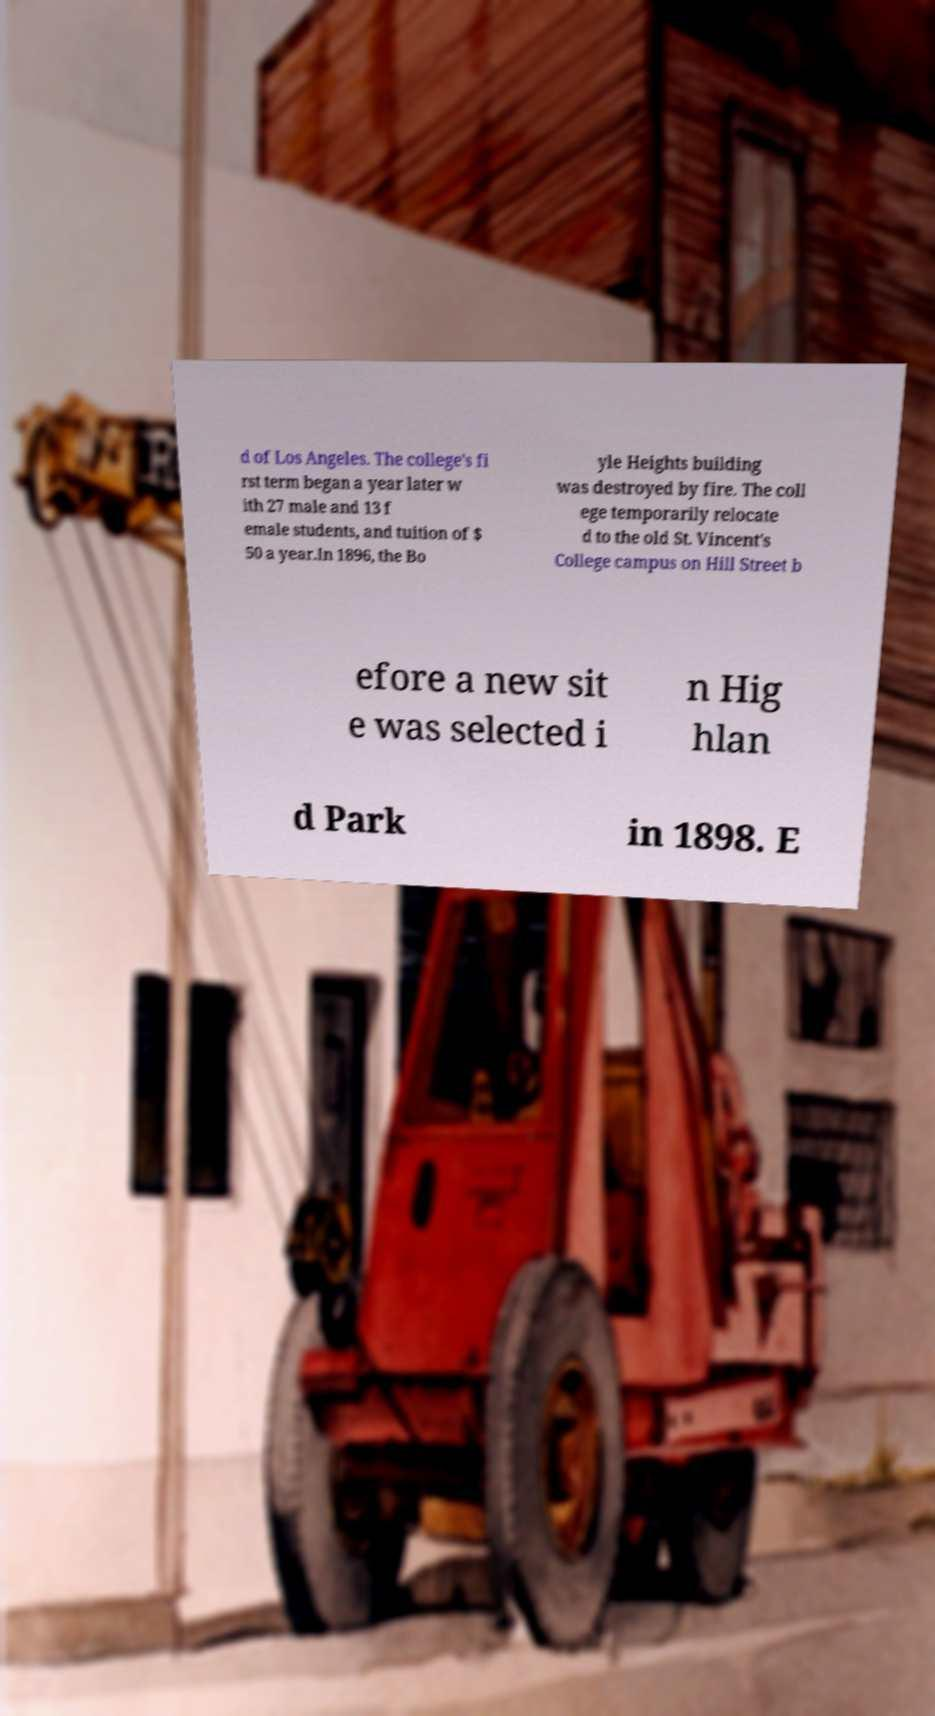For documentation purposes, I need the text within this image transcribed. Could you provide that? d of Los Angeles. The college's fi rst term began a year later w ith 27 male and 13 f emale students, and tuition of $ 50 a year.In 1896, the Bo yle Heights building was destroyed by fire. The coll ege temporarily relocate d to the old St. Vincent's College campus on Hill Street b efore a new sit e was selected i n Hig hlan d Park in 1898. E 